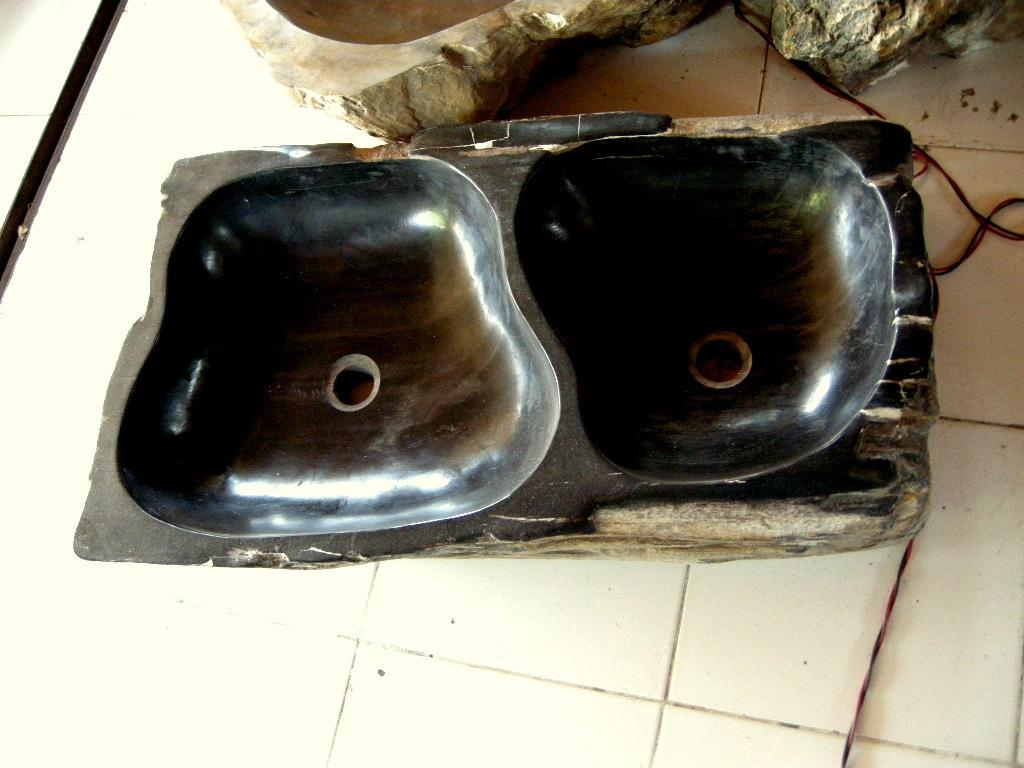What is the main subject in the center of the image? There is an object in the center of the image. What type of surface is visible at the bottom of the image? There is a floor visible at the bottom of the image. What else can be seen in the image besides the main subject? There are wires in the image. What can be observed in the background of the image? There are other objects in the background of the image. How does the glove compare to the cabbage in the image? There is no glove or cabbage present in the image. 